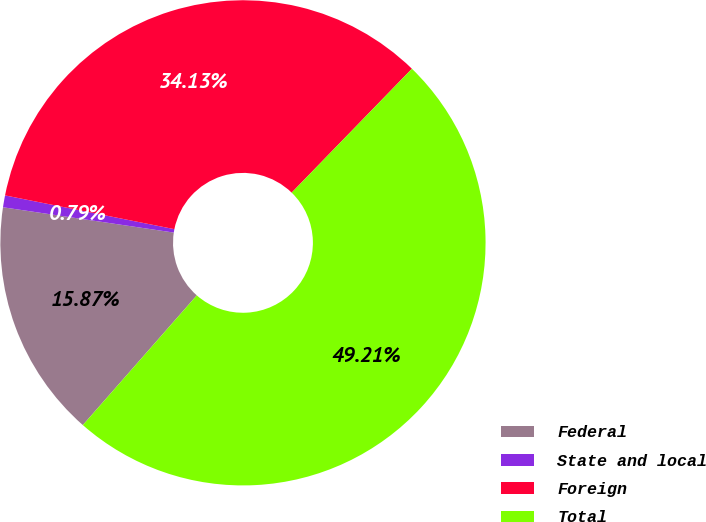Convert chart to OTSL. <chart><loc_0><loc_0><loc_500><loc_500><pie_chart><fcel>Federal<fcel>State and local<fcel>Foreign<fcel>Total<nl><fcel>15.87%<fcel>0.79%<fcel>34.13%<fcel>49.21%<nl></chart> 